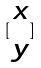Convert formula to latex. <formula><loc_0><loc_0><loc_500><loc_500>[ \begin{matrix} x \\ y \end{matrix} ]</formula> 